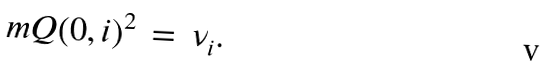Convert formula to latex. <formula><loc_0><loc_0><loc_500><loc_500>\ m Q ( 0 , i ) ^ { 2 } \, = \, \nu _ { i } .</formula> 